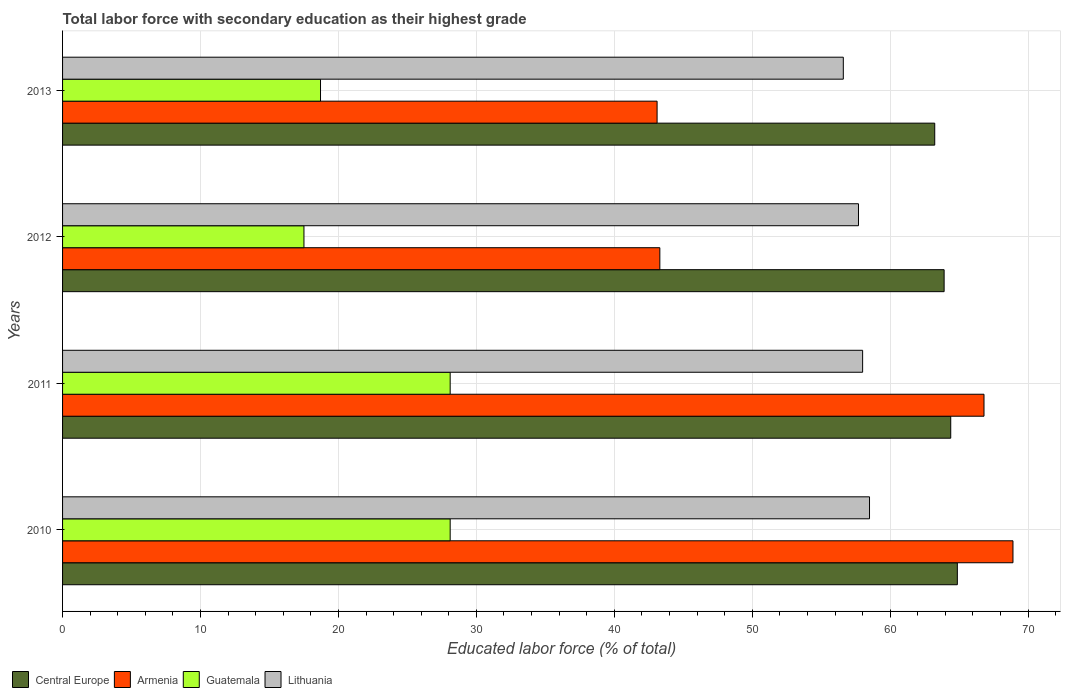Are the number of bars per tick equal to the number of legend labels?
Provide a short and direct response. Yes. Are the number of bars on each tick of the Y-axis equal?
Ensure brevity in your answer.  Yes. What is the percentage of total labor force with primary education in Central Europe in 2011?
Ensure brevity in your answer.  64.39. Across all years, what is the maximum percentage of total labor force with primary education in Lithuania?
Your answer should be compact. 58.5. Across all years, what is the minimum percentage of total labor force with primary education in Central Europe?
Keep it short and to the point. 63.23. In which year was the percentage of total labor force with primary education in Central Europe maximum?
Give a very brief answer. 2010. In which year was the percentage of total labor force with primary education in Lithuania minimum?
Your response must be concise. 2013. What is the total percentage of total labor force with primary education in Lithuania in the graph?
Provide a short and direct response. 230.8. What is the difference between the percentage of total labor force with primary education in Armenia in 2010 and that in 2012?
Ensure brevity in your answer.  25.6. What is the difference between the percentage of total labor force with primary education in Central Europe in 2010 and the percentage of total labor force with primary education in Guatemala in 2013?
Offer a terse response. 46.17. What is the average percentage of total labor force with primary education in Lithuania per year?
Provide a succinct answer. 57.7. In the year 2010, what is the difference between the percentage of total labor force with primary education in Lithuania and percentage of total labor force with primary education in Guatemala?
Your response must be concise. 30.4. What is the ratio of the percentage of total labor force with primary education in Guatemala in 2010 to that in 2012?
Your answer should be very brief. 1.61. Is the percentage of total labor force with primary education in Central Europe in 2011 less than that in 2012?
Keep it short and to the point. No. Is the difference between the percentage of total labor force with primary education in Lithuania in 2010 and 2013 greater than the difference between the percentage of total labor force with primary education in Guatemala in 2010 and 2013?
Ensure brevity in your answer.  No. What is the difference between the highest and the second highest percentage of total labor force with primary education in Armenia?
Offer a very short reply. 2.1. What is the difference between the highest and the lowest percentage of total labor force with primary education in Central Europe?
Your answer should be very brief. 1.64. Is it the case that in every year, the sum of the percentage of total labor force with primary education in Central Europe and percentage of total labor force with primary education in Lithuania is greater than the sum of percentage of total labor force with primary education in Guatemala and percentage of total labor force with primary education in Armenia?
Give a very brief answer. Yes. What does the 4th bar from the top in 2013 represents?
Your answer should be compact. Central Europe. What does the 1st bar from the bottom in 2012 represents?
Your answer should be compact. Central Europe. Is it the case that in every year, the sum of the percentage of total labor force with primary education in Central Europe and percentage of total labor force with primary education in Guatemala is greater than the percentage of total labor force with primary education in Lithuania?
Your answer should be very brief. Yes. Are all the bars in the graph horizontal?
Ensure brevity in your answer.  Yes. How many years are there in the graph?
Ensure brevity in your answer.  4. Does the graph contain grids?
Offer a very short reply. Yes. Where does the legend appear in the graph?
Offer a very short reply. Bottom left. How are the legend labels stacked?
Offer a very short reply. Horizontal. What is the title of the graph?
Your answer should be very brief. Total labor force with secondary education as their highest grade. Does "Thailand" appear as one of the legend labels in the graph?
Your answer should be very brief. No. What is the label or title of the X-axis?
Provide a short and direct response. Educated labor force (% of total). What is the label or title of the Y-axis?
Provide a short and direct response. Years. What is the Educated labor force (% of total) of Central Europe in 2010?
Your answer should be compact. 64.87. What is the Educated labor force (% of total) in Armenia in 2010?
Offer a very short reply. 68.9. What is the Educated labor force (% of total) of Guatemala in 2010?
Your answer should be compact. 28.1. What is the Educated labor force (% of total) in Lithuania in 2010?
Offer a very short reply. 58.5. What is the Educated labor force (% of total) of Central Europe in 2011?
Your answer should be very brief. 64.39. What is the Educated labor force (% of total) of Armenia in 2011?
Provide a short and direct response. 66.8. What is the Educated labor force (% of total) in Guatemala in 2011?
Offer a terse response. 28.1. What is the Educated labor force (% of total) of Lithuania in 2011?
Offer a very short reply. 58. What is the Educated labor force (% of total) of Central Europe in 2012?
Give a very brief answer. 63.91. What is the Educated labor force (% of total) of Armenia in 2012?
Provide a short and direct response. 43.3. What is the Educated labor force (% of total) in Guatemala in 2012?
Offer a terse response. 17.5. What is the Educated labor force (% of total) in Lithuania in 2012?
Provide a short and direct response. 57.7. What is the Educated labor force (% of total) in Central Europe in 2013?
Make the answer very short. 63.23. What is the Educated labor force (% of total) in Armenia in 2013?
Offer a very short reply. 43.1. What is the Educated labor force (% of total) in Guatemala in 2013?
Your answer should be compact. 18.7. What is the Educated labor force (% of total) in Lithuania in 2013?
Keep it short and to the point. 56.6. Across all years, what is the maximum Educated labor force (% of total) in Central Europe?
Ensure brevity in your answer.  64.87. Across all years, what is the maximum Educated labor force (% of total) of Armenia?
Ensure brevity in your answer.  68.9. Across all years, what is the maximum Educated labor force (% of total) of Guatemala?
Provide a short and direct response. 28.1. Across all years, what is the maximum Educated labor force (% of total) in Lithuania?
Offer a terse response. 58.5. Across all years, what is the minimum Educated labor force (% of total) in Central Europe?
Give a very brief answer. 63.23. Across all years, what is the minimum Educated labor force (% of total) in Armenia?
Your response must be concise. 43.1. Across all years, what is the minimum Educated labor force (% of total) of Lithuania?
Your response must be concise. 56.6. What is the total Educated labor force (% of total) of Central Europe in the graph?
Keep it short and to the point. 256.39. What is the total Educated labor force (% of total) in Armenia in the graph?
Offer a very short reply. 222.1. What is the total Educated labor force (% of total) in Guatemala in the graph?
Your answer should be compact. 92.4. What is the total Educated labor force (% of total) of Lithuania in the graph?
Your response must be concise. 230.8. What is the difference between the Educated labor force (% of total) in Central Europe in 2010 and that in 2011?
Keep it short and to the point. 0.48. What is the difference between the Educated labor force (% of total) of Armenia in 2010 and that in 2011?
Offer a terse response. 2.1. What is the difference between the Educated labor force (% of total) of Lithuania in 2010 and that in 2011?
Provide a short and direct response. 0.5. What is the difference between the Educated labor force (% of total) in Central Europe in 2010 and that in 2012?
Offer a terse response. 0.96. What is the difference between the Educated labor force (% of total) in Armenia in 2010 and that in 2012?
Give a very brief answer. 25.6. What is the difference between the Educated labor force (% of total) of Guatemala in 2010 and that in 2012?
Make the answer very short. 10.6. What is the difference between the Educated labor force (% of total) of Lithuania in 2010 and that in 2012?
Ensure brevity in your answer.  0.8. What is the difference between the Educated labor force (% of total) in Central Europe in 2010 and that in 2013?
Provide a short and direct response. 1.64. What is the difference between the Educated labor force (% of total) in Armenia in 2010 and that in 2013?
Offer a very short reply. 25.8. What is the difference between the Educated labor force (% of total) of Guatemala in 2010 and that in 2013?
Provide a short and direct response. 9.4. What is the difference between the Educated labor force (% of total) in Lithuania in 2010 and that in 2013?
Your answer should be compact. 1.9. What is the difference between the Educated labor force (% of total) of Central Europe in 2011 and that in 2012?
Give a very brief answer. 0.48. What is the difference between the Educated labor force (% of total) in Armenia in 2011 and that in 2012?
Your response must be concise. 23.5. What is the difference between the Educated labor force (% of total) in Central Europe in 2011 and that in 2013?
Make the answer very short. 1.16. What is the difference between the Educated labor force (% of total) of Armenia in 2011 and that in 2013?
Keep it short and to the point. 23.7. What is the difference between the Educated labor force (% of total) in Central Europe in 2012 and that in 2013?
Your response must be concise. 0.68. What is the difference between the Educated labor force (% of total) of Armenia in 2012 and that in 2013?
Your response must be concise. 0.2. What is the difference between the Educated labor force (% of total) of Guatemala in 2012 and that in 2013?
Keep it short and to the point. -1.2. What is the difference between the Educated labor force (% of total) in Lithuania in 2012 and that in 2013?
Your response must be concise. 1.1. What is the difference between the Educated labor force (% of total) of Central Europe in 2010 and the Educated labor force (% of total) of Armenia in 2011?
Offer a very short reply. -1.93. What is the difference between the Educated labor force (% of total) of Central Europe in 2010 and the Educated labor force (% of total) of Guatemala in 2011?
Provide a succinct answer. 36.77. What is the difference between the Educated labor force (% of total) of Central Europe in 2010 and the Educated labor force (% of total) of Lithuania in 2011?
Offer a very short reply. 6.87. What is the difference between the Educated labor force (% of total) of Armenia in 2010 and the Educated labor force (% of total) of Guatemala in 2011?
Make the answer very short. 40.8. What is the difference between the Educated labor force (% of total) of Guatemala in 2010 and the Educated labor force (% of total) of Lithuania in 2011?
Offer a terse response. -29.9. What is the difference between the Educated labor force (% of total) in Central Europe in 2010 and the Educated labor force (% of total) in Armenia in 2012?
Make the answer very short. 21.57. What is the difference between the Educated labor force (% of total) of Central Europe in 2010 and the Educated labor force (% of total) of Guatemala in 2012?
Offer a terse response. 47.37. What is the difference between the Educated labor force (% of total) of Central Europe in 2010 and the Educated labor force (% of total) of Lithuania in 2012?
Offer a very short reply. 7.17. What is the difference between the Educated labor force (% of total) in Armenia in 2010 and the Educated labor force (% of total) in Guatemala in 2012?
Provide a succinct answer. 51.4. What is the difference between the Educated labor force (% of total) of Armenia in 2010 and the Educated labor force (% of total) of Lithuania in 2012?
Provide a short and direct response. 11.2. What is the difference between the Educated labor force (% of total) in Guatemala in 2010 and the Educated labor force (% of total) in Lithuania in 2012?
Make the answer very short. -29.6. What is the difference between the Educated labor force (% of total) of Central Europe in 2010 and the Educated labor force (% of total) of Armenia in 2013?
Offer a very short reply. 21.77. What is the difference between the Educated labor force (% of total) in Central Europe in 2010 and the Educated labor force (% of total) in Guatemala in 2013?
Your response must be concise. 46.17. What is the difference between the Educated labor force (% of total) of Central Europe in 2010 and the Educated labor force (% of total) of Lithuania in 2013?
Offer a very short reply. 8.27. What is the difference between the Educated labor force (% of total) of Armenia in 2010 and the Educated labor force (% of total) of Guatemala in 2013?
Keep it short and to the point. 50.2. What is the difference between the Educated labor force (% of total) of Armenia in 2010 and the Educated labor force (% of total) of Lithuania in 2013?
Your answer should be very brief. 12.3. What is the difference between the Educated labor force (% of total) of Guatemala in 2010 and the Educated labor force (% of total) of Lithuania in 2013?
Your answer should be compact. -28.5. What is the difference between the Educated labor force (% of total) of Central Europe in 2011 and the Educated labor force (% of total) of Armenia in 2012?
Your answer should be very brief. 21.09. What is the difference between the Educated labor force (% of total) in Central Europe in 2011 and the Educated labor force (% of total) in Guatemala in 2012?
Give a very brief answer. 46.89. What is the difference between the Educated labor force (% of total) of Central Europe in 2011 and the Educated labor force (% of total) of Lithuania in 2012?
Provide a succinct answer. 6.69. What is the difference between the Educated labor force (% of total) of Armenia in 2011 and the Educated labor force (% of total) of Guatemala in 2012?
Provide a short and direct response. 49.3. What is the difference between the Educated labor force (% of total) in Armenia in 2011 and the Educated labor force (% of total) in Lithuania in 2012?
Offer a terse response. 9.1. What is the difference between the Educated labor force (% of total) in Guatemala in 2011 and the Educated labor force (% of total) in Lithuania in 2012?
Ensure brevity in your answer.  -29.6. What is the difference between the Educated labor force (% of total) in Central Europe in 2011 and the Educated labor force (% of total) in Armenia in 2013?
Provide a short and direct response. 21.29. What is the difference between the Educated labor force (% of total) in Central Europe in 2011 and the Educated labor force (% of total) in Guatemala in 2013?
Offer a very short reply. 45.69. What is the difference between the Educated labor force (% of total) of Central Europe in 2011 and the Educated labor force (% of total) of Lithuania in 2013?
Offer a terse response. 7.79. What is the difference between the Educated labor force (% of total) in Armenia in 2011 and the Educated labor force (% of total) in Guatemala in 2013?
Your answer should be compact. 48.1. What is the difference between the Educated labor force (% of total) of Armenia in 2011 and the Educated labor force (% of total) of Lithuania in 2013?
Keep it short and to the point. 10.2. What is the difference between the Educated labor force (% of total) of Guatemala in 2011 and the Educated labor force (% of total) of Lithuania in 2013?
Give a very brief answer. -28.5. What is the difference between the Educated labor force (% of total) of Central Europe in 2012 and the Educated labor force (% of total) of Armenia in 2013?
Give a very brief answer. 20.81. What is the difference between the Educated labor force (% of total) in Central Europe in 2012 and the Educated labor force (% of total) in Guatemala in 2013?
Keep it short and to the point. 45.21. What is the difference between the Educated labor force (% of total) in Central Europe in 2012 and the Educated labor force (% of total) in Lithuania in 2013?
Provide a succinct answer. 7.31. What is the difference between the Educated labor force (% of total) of Armenia in 2012 and the Educated labor force (% of total) of Guatemala in 2013?
Your answer should be very brief. 24.6. What is the difference between the Educated labor force (% of total) in Armenia in 2012 and the Educated labor force (% of total) in Lithuania in 2013?
Ensure brevity in your answer.  -13.3. What is the difference between the Educated labor force (% of total) in Guatemala in 2012 and the Educated labor force (% of total) in Lithuania in 2013?
Your response must be concise. -39.1. What is the average Educated labor force (% of total) of Central Europe per year?
Provide a short and direct response. 64.1. What is the average Educated labor force (% of total) in Armenia per year?
Give a very brief answer. 55.52. What is the average Educated labor force (% of total) of Guatemala per year?
Offer a terse response. 23.1. What is the average Educated labor force (% of total) in Lithuania per year?
Offer a very short reply. 57.7. In the year 2010, what is the difference between the Educated labor force (% of total) of Central Europe and Educated labor force (% of total) of Armenia?
Ensure brevity in your answer.  -4.03. In the year 2010, what is the difference between the Educated labor force (% of total) in Central Europe and Educated labor force (% of total) in Guatemala?
Your answer should be very brief. 36.77. In the year 2010, what is the difference between the Educated labor force (% of total) of Central Europe and Educated labor force (% of total) of Lithuania?
Offer a terse response. 6.37. In the year 2010, what is the difference between the Educated labor force (% of total) of Armenia and Educated labor force (% of total) of Guatemala?
Ensure brevity in your answer.  40.8. In the year 2010, what is the difference between the Educated labor force (% of total) in Armenia and Educated labor force (% of total) in Lithuania?
Offer a very short reply. 10.4. In the year 2010, what is the difference between the Educated labor force (% of total) of Guatemala and Educated labor force (% of total) of Lithuania?
Provide a short and direct response. -30.4. In the year 2011, what is the difference between the Educated labor force (% of total) in Central Europe and Educated labor force (% of total) in Armenia?
Make the answer very short. -2.41. In the year 2011, what is the difference between the Educated labor force (% of total) of Central Europe and Educated labor force (% of total) of Guatemala?
Ensure brevity in your answer.  36.29. In the year 2011, what is the difference between the Educated labor force (% of total) in Central Europe and Educated labor force (% of total) in Lithuania?
Provide a succinct answer. 6.39. In the year 2011, what is the difference between the Educated labor force (% of total) of Armenia and Educated labor force (% of total) of Guatemala?
Make the answer very short. 38.7. In the year 2011, what is the difference between the Educated labor force (% of total) in Guatemala and Educated labor force (% of total) in Lithuania?
Your answer should be compact. -29.9. In the year 2012, what is the difference between the Educated labor force (% of total) of Central Europe and Educated labor force (% of total) of Armenia?
Your response must be concise. 20.61. In the year 2012, what is the difference between the Educated labor force (% of total) in Central Europe and Educated labor force (% of total) in Guatemala?
Your answer should be compact. 46.41. In the year 2012, what is the difference between the Educated labor force (% of total) in Central Europe and Educated labor force (% of total) in Lithuania?
Keep it short and to the point. 6.21. In the year 2012, what is the difference between the Educated labor force (% of total) in Armenia and Educated labor force (% of total) in Guatemala?
Ensure brevity in your answer.  25.8. In the year 2012, what is the difference between the Educated labor force (% of total) in Armenia and Educated labor force (% of total) in Lithuania?
Your answer should be compact. -14.4. In the year 2012, what is the difference between the Educated labor force (% of total) in Guatemala and Educated labor force (% of total) in Lithuania?
Keep it short and to the point. -40.2. In the year 2013, what is the difference between the Educated labor force (% of total) in Central Europe and Educated labor force (% of total) in Armenia?
Give a very brief answer. 20.13. In the year 2013, what is the difference between the Educated labor force (% of total) of Central Europe and Educated labor force (% of total) of Guatemala?
Offer a terse response. 44.53. In the year 2013, what is the difference between the Educated labor force (% of total) in Central Europe and Educated labor force (% of total) in Lithuania?
Offer a very short reply. 6.63. In the year 2013, what is the difference between the Educated labor force (% of total) of Armenia and Educated labor force (% of total) of Guatemala?
Your response must be concise. 24.4. In the year 2013, what is the difference between the Educated labor force (% of total) of Guatemala and Educated labor force (% of total) of Lithuania?
Provide a short and direct response. -37.9. What is the ratio of the Educated labor force (% of total) in Central Europe in 2010 to that in 2011?
Your response must be concise. 1.01. What is the ratio of the Educated labor force (% of total) of Armenia in 2010 to that in 2011?
Your response must be concise. 1.03. What is the ratio of the Educated labor force (% of total) in Guatemala in 2010 to that in 2011?
Offer a very short reply. 1. What is the ratio of the Educated labor force (% of total) in Lithuania in 2010 to that in 2011?
Offer a very short reply. 1.01. What is the ratio of the Educated labor force (% of total) in Central Europe in 2010 to that in 2012?
Offer a very short reply. 1.01. What is the ratio of the Educated labor force (% of total) in Armenia in 2010 to that in 2012?
Make the answer very short. 1.59. What is the ratio of the Educated labor force (% of total) in Guatemala in 2010 to that in 2012?
Provide a short and direct response. 1.61. What is the ratio of the Educated labor force (% of total) of Lithuania in 2010 to that in 2012?
Your response must be concise. 1.01. What is the ratio of the Educated labor force (% of total) of Central Europe in 2010 to that in 2013?
Offer a very short reply. 1.03. What is the ratio of the Educated labor force (% of total) in Armenia in 2010 to that in 2013?
Offer a terse response. 1.6. What is the ratio of the Educated labor force (% of total) in Guatemala in 2010 to that in 2013?
Ensure brevity in your answer.  1.5. What is the ratio of the Educated labor force (% of total) of Lithuania in 2010 to that in 2013?
Ensure brevity in your answer.  1.03. What is the ratio of the Educated labor force (% of total) of Central Europe in 2011 to that in 2012?
Keep it short and to the point. 1.01. What is the ratio of the Educated labor force (% of total) of Armenia in 2011 to that in 2012?
Your answer should be very brief. 1.54. What is the ratio of the Educated labor force (% of total) in Guatemala in 2011 to that in 2012?
Make the answer very short. 1.61. What is the ratio of the Educated labor force (% of total) in Central Europe in 2011 to that in 2013?
Ensure brevity in your answer.  1.02. What is the ratio of the Educated labor force (% of total) in Armenia in 2011 to that in 2013?
Offer a terse response. 1.55. What is the ratio of the Educated labor force (% of total) of Guatemala in 2011 to that in 2013?
Offer a very short reply. 1.5. What is the ratio of the Educated labor force (% of total) of Lithuania in 2011 to that in 2013?
Provide a short and direct response. 1.02. What is the ratio of the Educated labor force (% of total) in Central Europe in 2012 to that in 2013?
Your answer should be compact. 1.01. What is the ratio of the Educated labor force (% of total) of Guatemala in 2012 to that in 2013?
Provide a short and direct response. 0.94. What is the ratio of the Educated labor force (% of total) of Lithuania in 2012 to that in 2013?
Ensure brevity in your answer.  1.02. What is the difference between the highest and the second highest Educated labor force (% of total) of Central Europe?
Make the answer very short. 0.48. What is the difference between the highest and the second highest Educated labor force (% of total) in Armenia?
Offer a very short reply. 2.1. What is the difference between the highest and the second highest Educated labor force (% of total) in Guatemala?
Ensure brevity in your answer.  0. What is the difference between the highest and the lowest Educated labor force (% of total) of Central Europe?
Offer a very short reply. 1.64. What is the difference between the highest and the lowest Educated labor force (% of total) in Armenia?
Offer a very short reply. 25.8. What is the difference between the highest and the lowest Educated labor force (% of total) in Guatemala?
Provide a succinct answer. 10.6. 